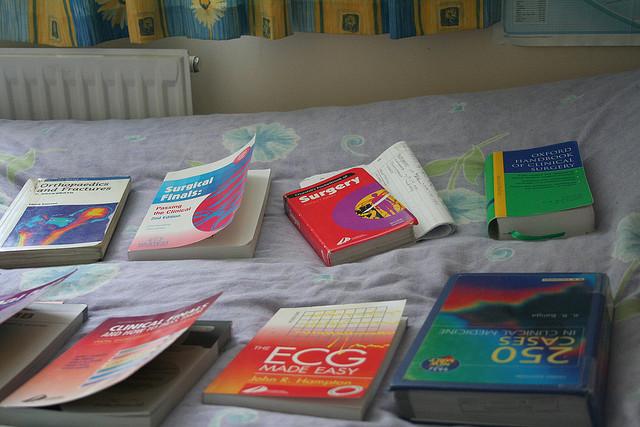Do you see a radiator in the picture?
Give a very brief answer. Yes. How many hardback books?
Write a very short answer. 2. For what type of degree would you need these books to study?
Short answer required. Phd. 